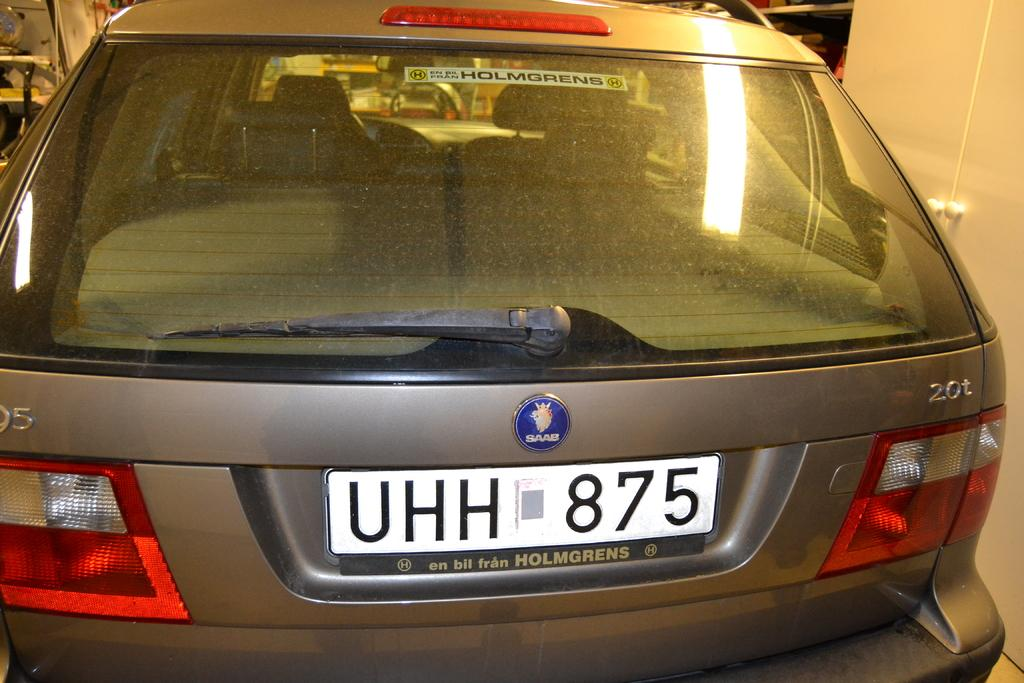<image>
Relay a brief, clear account of the picture shown. A license plate reading UHH 875 is on the back of a Saab. 